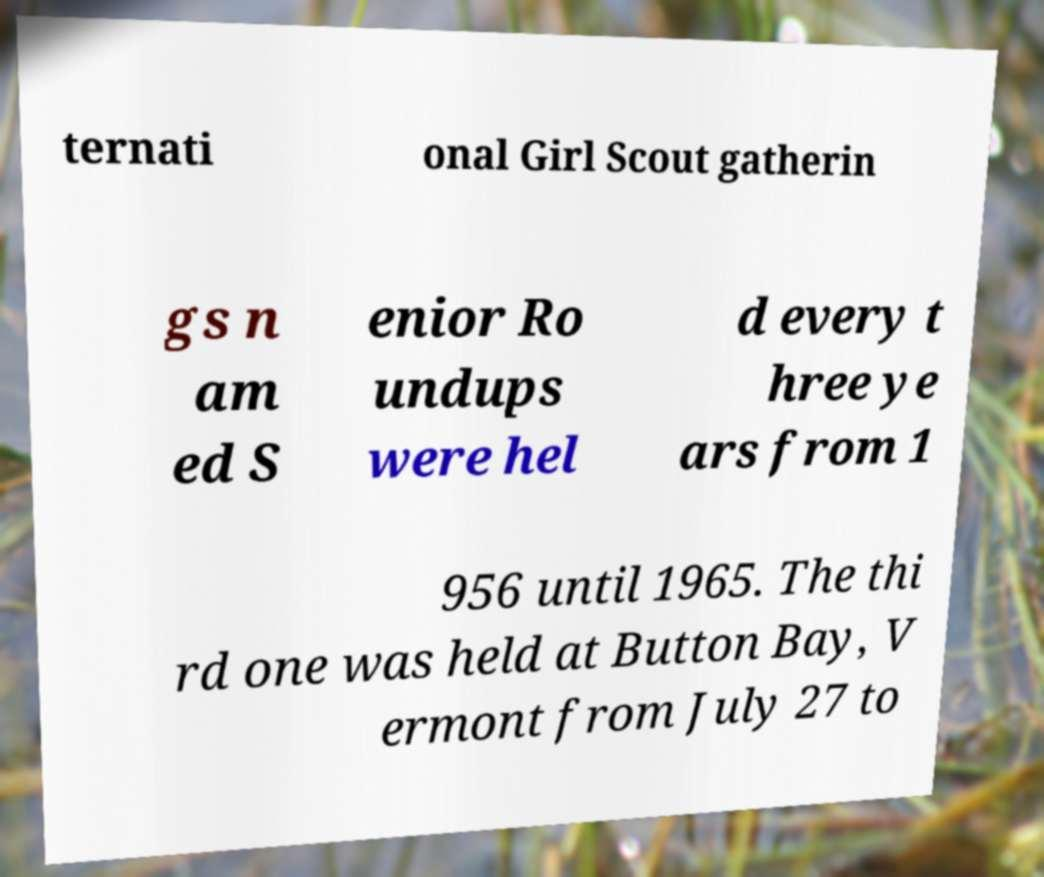Can you read and provide the text displayed in the image?This photo seems to have some interesting text. Can you extract and type it out for me? ternati onal Girl Scout gatherin gs n am ed S enior Ro undups were hel d every t hree ye ars from 1 956 until 1965. The thi rd one was held at Button Bay, V ermont from July 27 to 